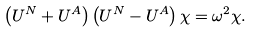<formula> <loc_0><loc_0><loc_500><loc_500>\left ( U ^ { N } + U ^ { A } \right ) \left ( U ^ { N } - U ^ { A } \right ) \chi = \omega ^ { 2 } \chi .</formula> 